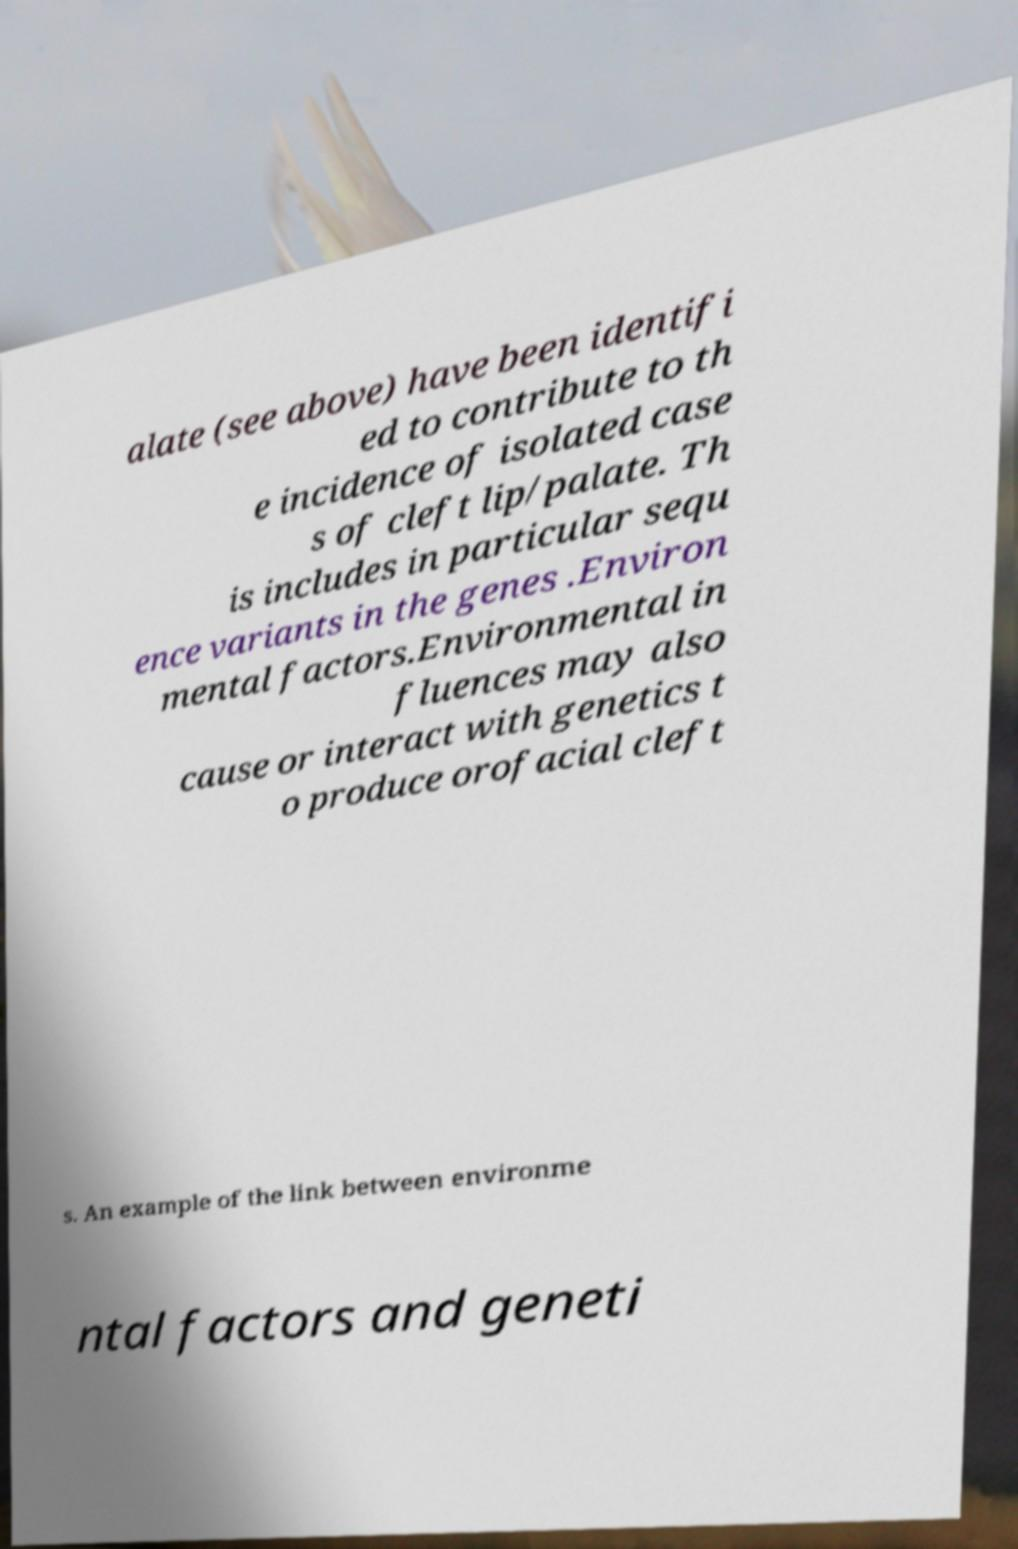Please read and relay the text visible in this image. What does it say? alate (see above) have been identifi ed to contribute to th e incidence of isolated case s of cleft lip/palate. Th is includes in particular sequ ence variants in the genes .Environ mental factors.Environmental in fluences may also cause or interact with genetics t o produce orofacial cleft s. An example of the link between environme ntal factors and geneti 